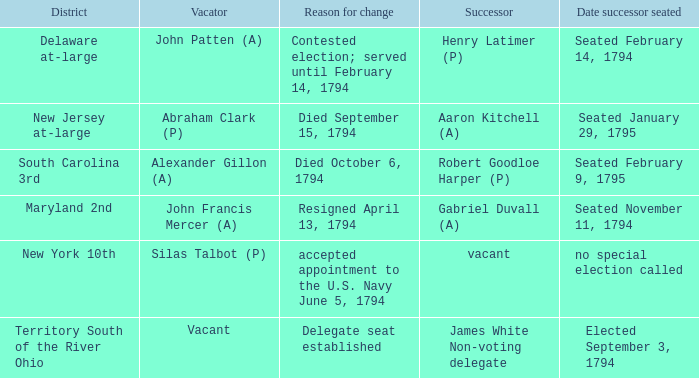Name the date successor seated for delegate seat established Elected September 3, 1794. 